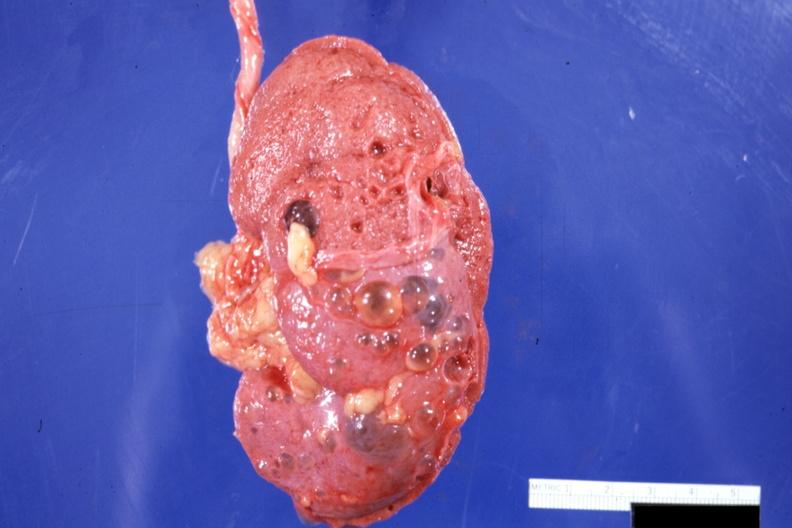s multiple cysts present?
Answer the question using a single word or phrase. Yes 